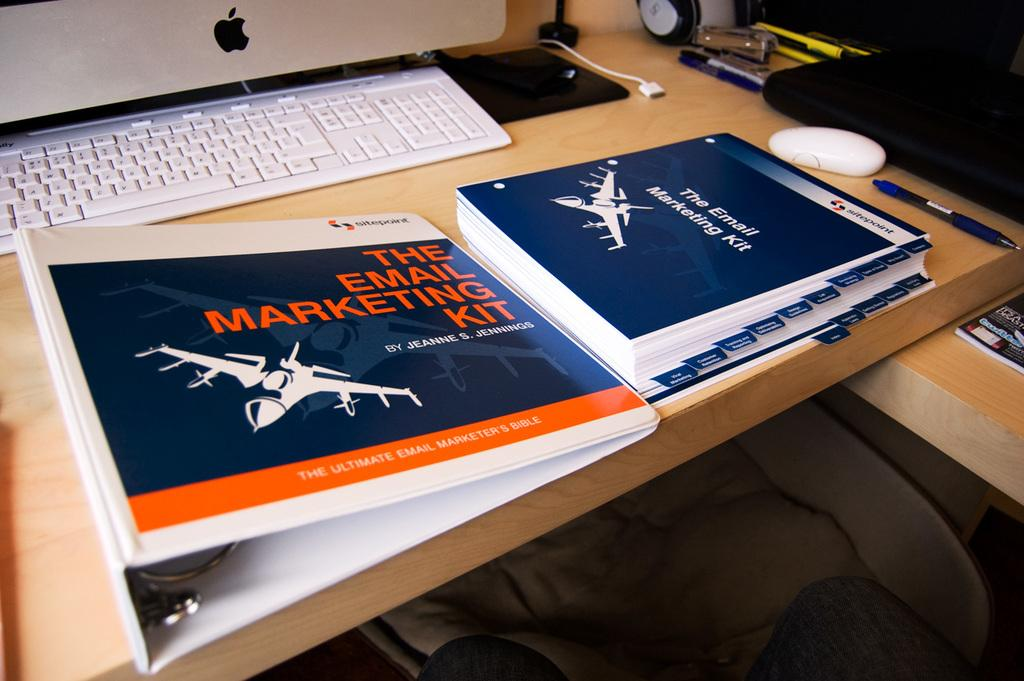<image>
Provide a brief description of the given image. A binder labelled Email Marketing Kit sits in front of a keyboard. 